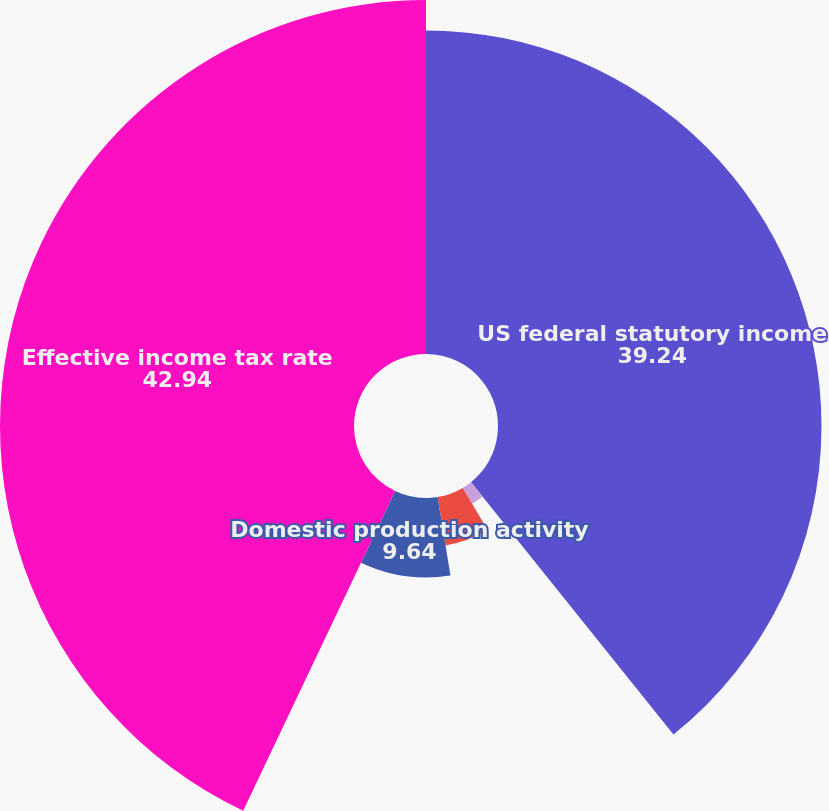Convert chart. <chart><loc_0><loc_0><loc_500><loc_500><pie_chart><fcel>US federal statutory income<fcel>State and local income taxes<fcel>Effect of foreign operations<fcel>Domestic production activity<fcel>Effective income tax rate<nl><fcel>39.24%<fcel>2.24%<fcel>5.94%<fcel>9.64%<fcel>42.94%<nl></chart> 